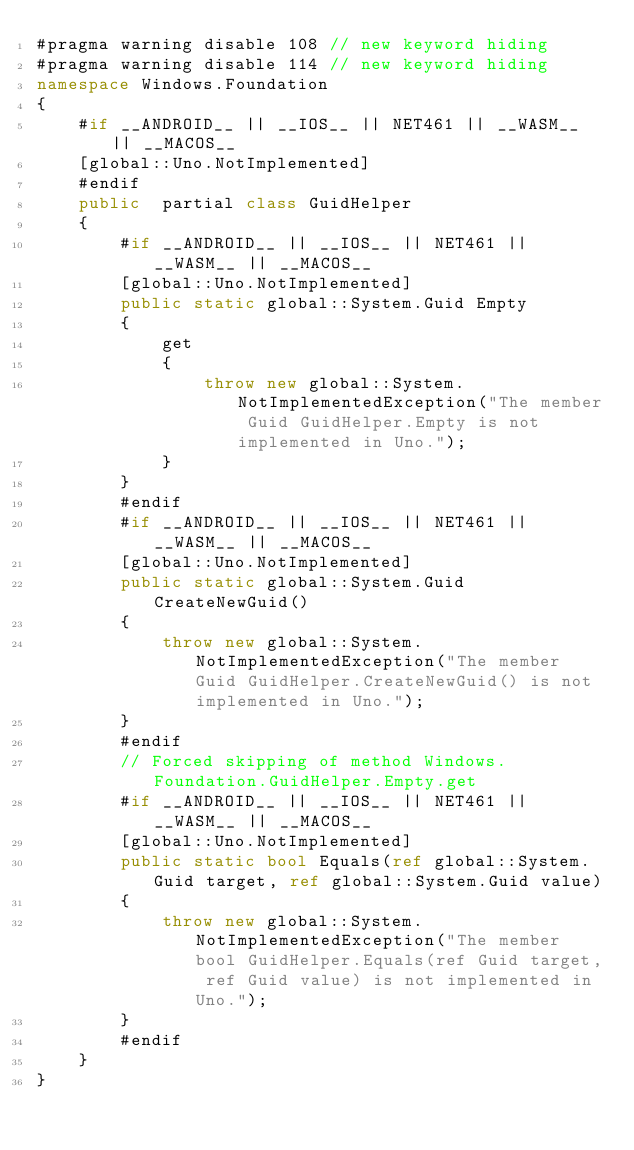<code> <loc_0><loc_0><loc_500><loc_500><_C#_>#pragma warning disable 108 // new keyword hiding
#pragma warning disable 114 // new keyword hiding
namespace Windows.Foundation
{
	#if __ANDROID__ || __IOS__ || NET461 || __WASM__ || __MACOS__
	[global::Uno.NotImplemented]
	#endif
	public  partial class GuidHelper 
	{
		#if __ANDROID__ || __IOS__ || NET461 || __WASM__ || __MACOS__
		[global::Uno.NotImplemented]
		public static global::System.Guid Empty
		{
			get
			{
				throw new global::System.NotImplementedException("The member Guid GuidHelper.Empty is not implemented in Uno.");
			}
		}
		#endif
		#if __ANDROID__ || __IOS__ || NET461 || __WASM__ || __MACOS__
		[global::Uno.NotImplemented]
		public static global::System.Guid CreateNewGuid()
		{
			throw new global::System.NotImplementedException("The member Guid GuidHelper.CreateNewGuid() is not implemented in Uno.");
		}
		#endif
		// Forced skipping of method Windows.Foundation.GuidHelper.Empty.get
		#if __ANDROID__ || __IOS__ || NET461 || __WASM__ || __MACOS__
		[global::Uno.NotImplemented]
		public static bool Equals(ref global::System.Guid target, ref global::System.Guid value)
		{
			throw new global::System.NotImplementedException("The member bool GuidHelper.Equals(ref Guid target, ref Guid value) is not implemented in Uno.");
		}
		#endif
	}
}
</code> 